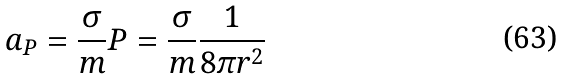Convert formula to latex. <formula><loc_0><loc_0><loc_500><loc_500>a _ { P } = \frac { \sigma } { m } P = \frac { \sigma } { m } \frac { 1 } { 8 \pi r ^ { 2 } }</formula> 